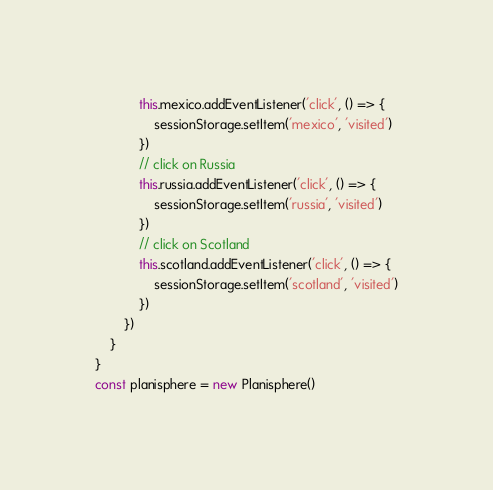<code> <loc_0><loc_0><loc_500><loc_500><_JavaScript_>            this.mexico.addEventListener('click', () => {
                sessionStorage.setItem('mexico', 'visited')
            })
            // click on Russia
            this.russia.addEventListener('click', () => {
                sessionStorage.setItem('russia', 'visited')
            })
            // click on Scotland
            this.scotland.addEventListener('click', () => {
                sessionStorage.setItem('scotland', 'visited')
            })
        })
    }
}
const planisphere = new Planisphere()</code> 